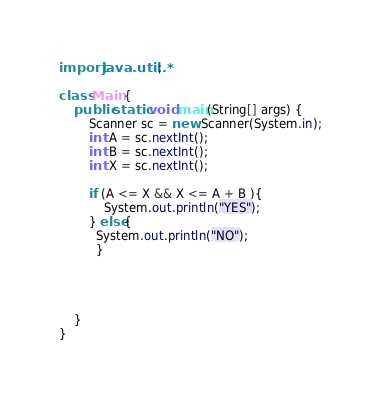Convert code to text. <code><loc_0><loc_0><loc_500><loc_500><_Java_>import java.util.*;

class Main {
    public static void main(String[] args) {
        Scanner sc = new Scanner(System.in);
        int A = sc.nextInt();
        int B = sc.nextInt();
        int X = sc.nextInt();
      
      	if (A <= X && X <= A + B ){
        	System.out.println("YES");
        } else{
          System.out.println("NO");
          }
     
        
      
      
    }
}
</code> 